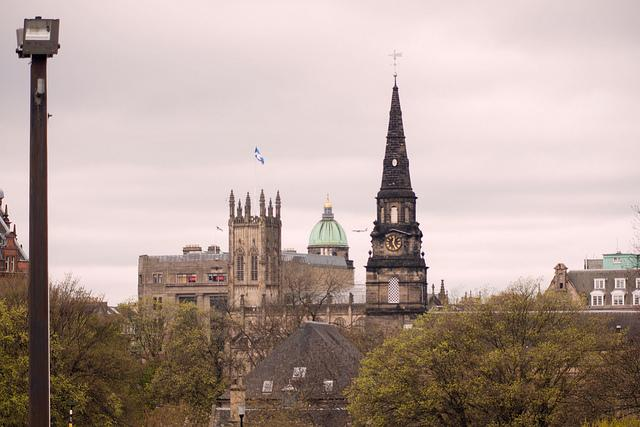What color is the wide dome in the background of the church? green 